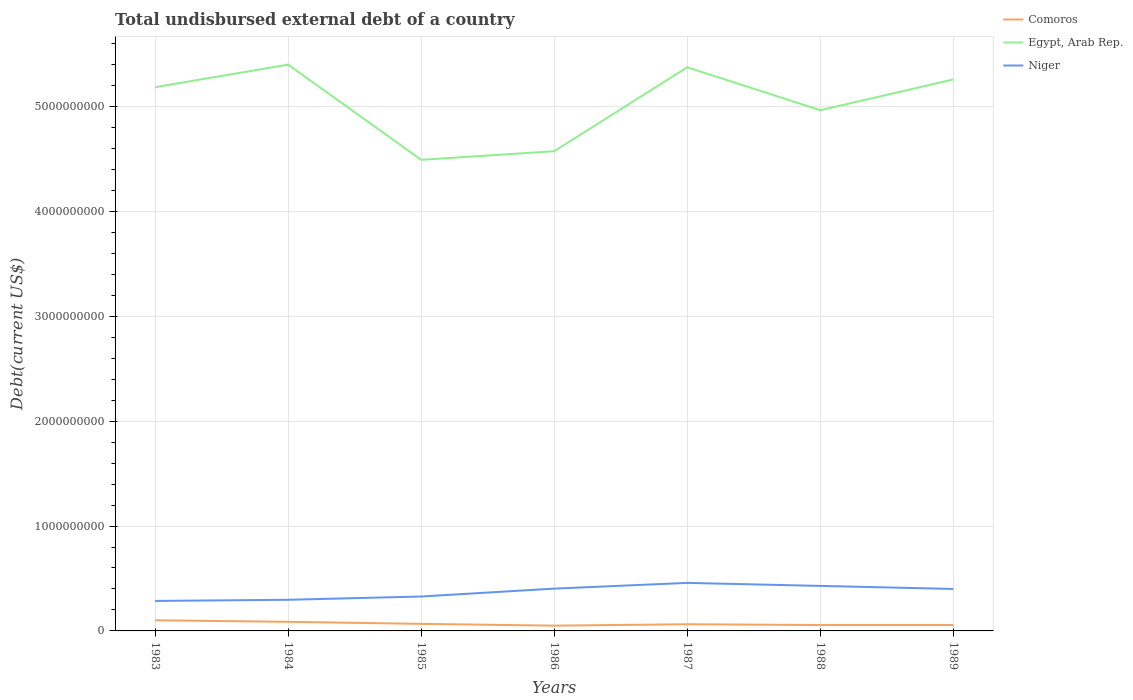Does the line corresponding to Comoros intersect with the line corresponding to Niger?
Keep it short and to the point. No. Is the number of lines equal to the number of legend labels?
Offer a very short reply. Yes. Across all years, what is the maximum total undisbursed external debt in Niger?
Provide a short and direct response. 2.86e+08. What is the total total undisbursed external debt in Egypt, Arab Rep. in the graph?
Your answer should be very brief. -8.00e+08. What is the difference between the highest and the second highest total undisbursed external debt in Egypt, Arab Rep.?
Your answer should be compact. 9.08e+08. What is the difference between the highest and the lowest total undisbursed external debt in Niger?
Your response must be concise. 4. Is the total undisbursed external debt in Niger strictly greater than the total undisbursed external debt in Egypt, Arab Rep. over the years?
Ensure brevity in your answer.  Yes. How many lines are there?
Your response must be concise. 3. How many years are there in the graph?
Provide a succinct answer. 7. What is the difference between two consecutive major ticks on the Y-axis?
Keep it short and to the point. 1.00e+09. Does the graph contain any zero values?
Provide a short and direct response. No. Does the graph contain grids?
Your answer should be compact. Yes. Where does the legend appear in the graph?
Offer a very short reply. Top right. How are the legend labels stacked?
Keep it short and to the point. Vertical. What is the title of the graph?
Your answer should be very brief. Total undisbursed external debt of a country. Does "Fiji" appear as one of the legend labels in the graph?
Keep it short and to the point. No. What is the label or title of the X-axis?
Provide a short and direct response. Years. What is the label or title of the Y-axis?
Offer a very short reply. Debt(current US$). What is the Debt(current US$) of Comoros in 1983?
Ensure brevity in your answer.  1.01e+08. What is the Debt(current US$) in Egypt, Arab Rep. in 1983?
Offer a very short reply. 5.18e+09. What is the Debt(current US$) in Niger in 1983?
Give a very brief answer. 2.86e+08. What is the Debt(current US$) in Comoros in 1984?
Your response must be concise. 8.66e+07. What is the Debt(current US$) of Egypt, Arab Rep. in 1984?
Give a very brief answer. 5.40e+09. What is the Debt(current US$) of Niger in 1984?
Make the answer very short. 2.97e+08. What is the Debt(current US$) in Comoros in 1985?
Offer a very short reply. 6.73e+07. What is the Debt(current US$) in Egypt, Arab Rep. in 1985?
Offer a terse response. 4.49e+09. What is the Debt(current US$) of Niger in 1985?
Your answer should be compact. 3.28e+08. What is the Debt(current US$) in Comoros in 1986?
Ensure brevity in your answer.  5.02e+07. What is the Debt(current US$) of Egypt, Arab Rep. in 1986?
Ensure brevity in your answer.  4.57e+09. What is the Debt(current US$) in Niger in 1986?
Provide a short and direct response. 4.03e+08. What is the Debt(current US$) of Comoros in 1987?
Keep it short and to the point. 6.37e+07. What is the Debt(current US$) of Egypt, Arab Rep. in 1987?
Your answer should be very brief. 5.37e+09. What is the Debt(current US$) in Niger in 1987?
Your answer should be very brief. 4.58e+08. What is the Debt(current US$) in Comoros in 1988?
Ensure brevity in your answer.  5.61e+07. What is the Debt(current US$) in Egypt, Arab Rep. in 1988?
Give a very brief answer. 4.96e+09. What is the Debt(current US$) in Niger in 1988?
Your answer should be compact. 4.29e+08. What is the Debt(current US$) of Comoros in 1989?
Your response must be concise. 5.61e+07. What is the Debt(current US$) in Egypt, Arab Rep. in 1989?
Ensure brevity in your answer.  5.26e+09. What is the Debt(current US$) in Niger in 1989?
Give a very brief answer. 4.00e+08. Across all years, what is the maximum Debt(current US$) of Comoros?
Your answer should be compact. 1.01e+08. Across all years, what is the maximum Debt(current US$) of Egypt, Arab Rep.?
Your answer should be compact. 5.40e+09. Across all years, what is the maximum Debt(current US$) of Niger?
Your answer should be very brief. 4.58e+08. Across all years, what is the minimum Debt(current US$) in Comoros?
Keep it short and to the point. 5.02e+07. Across all years, what is the minimum Debt(current US$) in Egypt, Arab Rep.?
Your answer should be compact. 4.49e+09. Across all years, what is the minimum Debt(current US$) in Niger?
Provide a short and direct response. 2.86e+08. What is the total Debt(current US$) of Comoros in the graph?
Make the answer very short. 4.82e+08. What is the total Debt(current US$) in Egypt, Arab Rep. in the graph?
Offer a terse response. 3.52e+1. What is the total Debt(current US$) in Niger in the graph?
Provide a succinct answer. 2.60e+09. What is the difference between the Debt(current US$) in Comoros in 1983 and that in 1984?
Give a very brief answer. 1.48e+07. What is the difference between the Debt(current US$) in Egypt, Arab Rep. in 1983 and that in 1984?
Your answer should be compact. -2.15e+08. What is the difference between the Debt(current US$) of Niger in 1983 and that in 1984?
Your response must be concise. -1.10e+07. What is the difference between the Debt(current US$) in Comoros in 1983 and that in 1985?
Make the answer very short. 3.41e+07. What is the difference between the Debt(current US$) of Egypt, Arab Rep. in 1983 and that in 1985?
Ensure brevity in your answer.  6.93e+08. What is the difference between the Debt(current US$) in Niger in 1983 and that in 1985?
Offer a very short reply. -4.22e+07. What is the difference between the Debt(current US$) of Comoros in 1983 and that in 1986?
Your answer should be compact. 5.13e+07. What is the difference between the Debt(current US$) in Egypt, Arab Rep. in 1983 and that in 1986?
Provide a short and direct response. 6.11e+08. What is the difference between the Debt(current US$) in Niger in 1983 and that in 1986?
Your response must be concise. -1.17e+08. What is the difference between the Debt(current US$) of Comoros in 1983 and that in 1987?
Make the answer very short. 3.77e+07. What is the difference between the Debt(current US$) in Egypt, Arab Rep. in 1983 and that in 1987?
Provide a short and direct response. -1.90e+08. What is the difference between the Debt(current US$) in Niger in 1983 and that in 1987?
Ensure brevity in your answer.  -1.72e+08. What is the difference between the Debt(current US$) of Comoros in 1983 and that in 1988?
Your answer should be very brief. 4.54e+07. What is the difference between the Debt(current US$) of Egypt, Arab Rep. in 1983 and that in 1988?
Your response must be concise. 2.20e+08. What is the difference between the Debt(current US$) of Niger in 1983 and that in 1988?
Make the answer very short. -1.43e+08. What is the difference between the Debt(current US$) of Comoros in 1983 and that in 1989?
Your response must be concise. 4.53e+07. What is the difference between the Debt(current US$) in Egypt, Arab Rep. in 1983 and that in 1989?
Keep it short and to the point. -7.38e+07. What is the difference between the Debt(current US$) in Niger in 1983 and that in 1989?
Give a very brief answer. -1.14e+08. What is the difference between the Debt(current US$) in Comoros in 1984 and that in 1985?
Your answer should be very brief. 1.93e+07. What is the difference between the Debt(current US$) in Egypt, Arab Rep. in 1984 and that in 1985?
Make the answer very short. 9.08e+08. What is the difference between the Debt(current US$) of Niger in 1984 and that in 1985?
Your answer should be compact. -3.13e+07. What is the difference between the Debt(current US$) of Comoros in 1984 and that in 1986?
Your answer should be very brief. 3.65e+07. What is the difference between the Debt(current US$) in Egypt, Arab Rep. in 1984 and that in 1986?
Give a very brief answer. 8.26e+08. What is the difference between the Debt(current US$) in Niger in 1984 and that in 1986?
Offer a very short reply. -1.07e+08. What is the difference between the Debt(current US$) in Comoros in 1984 and that in 1987?
Your answer should be compact. 2.29e+07. What is the difference between the Debt(current US$) of Egypt, Arab Rep. in 1984 and that in 1987?
Your response must be concise. 2.53e+07. What is the difference between the Debt(current US$) in Niger in 1984 and that in 1987?
Make the answer very short. -1.61e+08. What is the difference between the Debt(current US$) of Comoros in 1984 and that in 1988?
Your answer should be very brief. 3.05e+07. What is the difference between the Debt(current US$) of Egypt, Arab Rep. in 1984 and that in 1988?
Offer a terse response. 4.35e+08. What is the difference between the Debt(current US$) in Niger in 1984 and that in 1988?
Offer a terse response. -1.32e+08. What is the difference between the Debt(current US$) of Comoros in 1984 and that in 1989?
Your answer should be very brief. 3.05e+07. What is the difference between the Debt(current US$) in Egypt, Arab Rep. in 1984 and that in 1989?
Ensure brevity in your answer.  1.41e+08. What is the difference between the Debt(current US$) of Niger in 1984 and that in 1989?
Provide a succinct answer. -1.03e+08. What is the difference between the Debt(current US$) in Comoros in 1985 and that in 1986?
Your response must be concise. 1.72e+07. What is the difference between the Debt(current US$) in Egypt, Arab Rep. in 1985 and that in 1986?
Offer a terse response. -8.19e+07. What is the difference between the Debt(current US$) in Niger in 1985 and that in 1986?
Offer a terse response. -7.53e+07. What is the difference between the Debt(current US$) of Comoros in 1985 and that in 1987?
Offer a very short reply. 3.61e+06. What is the difference between the Debt(current US$) in Egypt, Arab Rep. in 1985 and that in 1987?
Provide a succinct answer. -8.82e+08. What is the difference between the Debt(current US$) in Niger in 1985 and that in 1987?
Offer a very short reply. -1.30e+08. What is the difference between the Debt(current US$) of Comoros in 1985 and that in 1988?
Offer a very short reply. 1.12e+07. What is the difference between the Debt(current US$) of Egypt, Arab Rep. in 1985 and that in 1988?
Your response must be concise. -4.73e+08. What is the difference between the Debt(current US$) of Niger in 1985 and that in 1988?
Your answer should be very brief. -1.01e+08. What is the difference between the Debt(current US$) in Comoros in 1985 and that in 1989?
Your answer should be very brief. 1.12e+07. What is the difference between the Debt(current US$) of Egypt, Arab Rep. in 1985 and that in 1989?
Keep it short and to the point. -7.66e+08. What is the difference between the Debt(current US$) in Niger in 1985 and that in 1989?
Ensure brevity in your answer.  -7.20e+07. What is the difference between the Debt(current US$) in Comoros in 1986 and that in 1987?
Your response must be concise. -1.36e+07. What is the difference between the Debt(current US$) of Egypt, Arab Rep. in 1986 and that in 1987?
Ensure brevity in your answer.  -8.00e+08. What is the difference between the Debt(current US$) of Niger in 1986 and that in 1987?
Keep it short and to the point. -5.46e+07. What is the difference between the Debt(current US$) of Comoros in 1986 and that in 1988?
Provide a succinct answer. -5.94e+06. What is the difference between the Debt(current US$) in Egypt, Arab Rep. in 1986 and that in 1988?
Give a very brief answer. -3.91e+08. What is the difference between the Debt(current US$) of Niger in 1986 and that in 1988?
Provide a succinct answer. -2.58e+07. What is the difference between the Debt(current US$) of Comoros in 1986 and that in 1989?
Ensure brevity in your answer.  -5.96e+06. What is the difference between the Debt(current US$) in Egypt, Arab Rep. in 1986 and that in 1989?
Give a very brief answer. -6.84e+08. What is the difference between the Debt(current US$) of Niger in 1986 and that in 1989?
Your response must be concise. 3.22e+06. What is the difference between the Debt(current US$) in Comoros in 1987 and that in 1988?
Your answer should be very brief. 7.61e+06. What is the difference between the Debt(current US$) of Egypt, Arab Rep. in 1987 and that in 1988?
Your answer should be very brief. 4.09e+08. What is the difference between the Debt(current US$) of Niger in 1987 and that in 1988?
Offer a terse response. 2.88e+07. What is the difference between the Debt(current US$) in Comoros in 1987 and that in 1989?
Provide a succinct answer. 7.58e+06. What is the difference between the Debt(current US$) of Egypt, Arab Rep. in 1987 and that in 1989?
Give a very brief answer. 1.16e+08. What is the difference between the Debt(current US$) of Niger in 1987 and that in 1989?
Offer a very short reply. 5.78e+07. What is the difference between the Debt(current US$) in Comoros in 1988 and that in 1989?
Your answer should be very brief. -2.90e+04. What is the difference between the Debt(current US$) of Egypt, Arab Rep. in 1988 and that in 1989?
Keep it short and to the point. -2.94e+08. What is the difference between the Debt(current US$) in Niger in 1988 and that in 1989?
Your answer should be compact. 2.90e+07. What is the difference between the Debt(current US$) in Comoros in 1983 and the Debt(current US$) in Egypt, Arab Rep. in 1984?
Provide a short and direct response. -5.30e+09. What is the difference between the Debt(current US$) of Comoros in 1983 and the Debt(current US$) of Niger in 1984?
Ensure brevity in your answer.  -1.95e+08. What is the difference between the Debt(current US$) of Egypt, Arab Rep. in 1983 and the Debt(current US$) of Niger in 1984?
Provide a short and direct response. 4.89e+09. What is the difference between the Debt(current US$) of Comoros in 1983 and the Debt(current US$) of Egypt, Arab Rep. in 1985?
Offer a very short reply. -4.39e+09. What is the difference between the Debt(current US$) in Comoros in 1983 and the Debt(current US$) in Niger in 1985?
Provide a succinct answer. -2.27e+08. What is the difference between the Debt(current US$) of Egypt, Arab Rep. in 1983 and the Debt(current US$) of Niger in 1985?
Your answer should be very brief. 4.86e+09. What is the difference between the Debt(current US$) in Comoros in 1983 and the Debt(current US$) in Egypt, Arab Rep. in 1986?
Provide a short and direct response. -4.47e+09. What is the difference between the Debt(current US$) in Comoros in 1983 and the Debt(current US$) in Niger in 1986?
Your response must be concise. -3.02e+08. What is the difference between the Debt(current US$) in Egypt, Arab Rep. in 1983 and the Debt(current US$) in Niger in 1986?
Ensure brevity in your answer.  4.78e+09. What is the difference between the Debt(current US$) of Comoros in 1983 and the Debt(current US$) of Egypt, Arab Rep. in 1987?
Give a very brief answer. -5.27e+09. What is the difference between the Debt(current US$) in Comoros in 1983 and the Debt(current US$) in Niger in 1987?
Keep it short and to the point. -3.56e+08. What is the difference between the Debt(current US$) of Egypt, Arab Rep. in 1983 and the Debt(current US$) of Niger in 1987?
Ensure brevity in your answer.  4.73e+09. What is the difference between the Debt(current US$) in Comoros in 1983 and the Debt(current US$) in Egypt, Arab Rep. in 1988?
Provide a short and direct response. -4.86e+09. What is the difference between the Debt(current US$) of Comoros in 1983 and the Debt(current US$) of Niger in 1988?
Your response must be concise. -3.28e+08. What is the difference between the Debt(current US$) in Egypt, Arab Rep. in 1983 and the Debt(current US$) in Niger in 1988?
Offer a terse response. 4.76e+09. What is the difference between the Debt(current US$) in Comoros in 1983 and the Debt(current US$) in Egypt, Arab Rep. in 1989?
Your answer should be very brief. -5.16e+09. What is the difference between the Debt(current US$) in Comoros in 1983 and the Debt(current US$) in Niger in 1989?
Give a very brief answer. -2.99e+08. What is the difference between the Debt(current US$) in Egypt, Arab Rep. in 1983 and the Debt(current US$) in Niger in 1989?
Make the answer very short. 4.78e+09. What is the difference between the Debt(current US$) in Comoros in 1984 and the Debt(current US$) in Egypt, Arab Rep. in 1985?
Offer a terse response. -4.41e+09. What is the difference between the Debt(current US$) of Comoros in 1984 and the Debt(current US$) of Niger in 1985?
Your answer should be very brief. -2.42e+08. What is the difference between the Debt(current US$) of Egypt, Arab Rep. in 1984 and the Debt(current US$) of Niger in 1985?
Make the answer very short. 5.07e+09. What is the difference between the Debt(current US$) of Comoros in 1984 and the Debt(current US$) of Egypt, Arab Rep. in 1986?
Offer a terse response. -4.49e+09. What is the difference between the Debt(current US$) in Comoros in 1984 and the Debt(current US$) in Niger in 1986?
Ensure brevity in your answer.  -3.17e+08. What is the difference between the Debt(current US$) in Egypt, Arab Rep. in 1984 and the Debt(current US$) in Niger in 1986?
Provide a short and direct response. 5.00e+09. What is the difference between the Debt(current US$) in Comoros in 1984 and the Debt(current US$) in Egypt, Arab Rep. in 1987?
Your response must be concise. -5.29e+09. What is the difference between the Debt(current US$) of Comoros in 1984 and the Debt(current US$) of Niger in 1987?
Ensure brevity in your answer.  -3.71e+08. What is the difference between the Debt(current US$) in Egypt, Arab Rep. in 1984 and the Debt(current US$) in Niger in 1987?
Offer a terse response. 4.94e+09. What is the difference between the Debt(current US$) of Comoros in 1984 and the Debt(current US$) of Egypt, Arab Rep. in 1988?
Your answer should be very brief. -4.88e+09. What is the difference between the Debt(current US$) in Comoros in 1984 and the Debt(current US$) in Niger in 1988?
Give a very brief answer. -3.43e+08. What is the difference between the Debt(current US$) in Egypt, Arab Rep. in 1984 and the Debt(current US$) in Niger in 1988?
Provide a succinct answer. 4.97e+09. What is the difference between the Debt(current US$) in Comoros in 1984 and the Debt(current US$) in Egypt, Arab Rep. in 1989?
Offer a very short reply. -5.17e+09. What is the difference between the Debt(current US$) of Comoros in 1984 and the Debt(current US$) of Niger in 1989?
Offer a terse response. -3.14e+08. What is the difference between the Debt(current US$) of Egypt, Arab Rep. in 1984 and the Debt(current US$) of Niger in 1989?
Your response must be concise. 5.00e+09. What is the difference between the Debt(current US$) in Comoros in 1985 and the Debt(current US$) in Egypt, Arab Rep. in 1986?
Your answer should be very brief. -4.51e+09. What is the difference between the Debt(current US$) of Comoros in 1985 and the Debt(current US$) of Niger in 1986?
Your answer should be compact. -3.36e+08. What is the difference between the Debt(current US$) in Egypt, Arab Rep. in 1985 and the Debt(current US$) in Niger in 1986?
Give a very brief answer. 4.09e+09. What is the difference between the Debt(current US$) of Comoros in 1985 and the Debt(current US$) of Egypt, Arab Rep. in 1987?
Provide a succinct answer. -5.31e+09. What is the difference between the Debt(current US$) of Comoros in 1985 and the Debt(current US$) of Niger in 1987?
Your response must be concise. -3.91e+08. What is the difference between the Debt(current US$) of Egypt, Arab Rep. in 1985 and the Debt(current US$) of Niger in 1987?
Your answer should be very brief. 4.03e+09. What is the difference between the Debt(current US$) of Comoros in 1985 and the Debt(current US$) of Egypt, Arab Rep. in 1988?
Make the answer very short. -4.90e+09. What is the difference between the Debt(current US$) of Comoros in 1985 and the Debt(current US$) of Niger in 1988?
Keep it short and to the point. -3.62e+08. What is the difference between the Debt(current US$) in Egypt, Arab Rep. in 1985 and the Debt(current US$) in Niger in 1988?
Provide a short and direct response. 4.06e+09. What is the difference between the Debt(current US$) in Comoros in 1985 and the Debt(current US$) in Egypt, Arab Rep. in 1989?
Your response must be concise. -5.19e+09. What is the difference between the Debt(current US$) of Comoros in 1985 and the Debt(current US$) of Niger in 1989?
Provide a succinct answer. -3.33e+08. What is the difference between the Debt(current US$) in Egypt, Arab Rep. in 1985 and the Debt(current US$) in Niger in 1989?
Your answer should be very brief. 4.09e+09. What is the difference between the Debt(current US$) in Comoros in 1986 and the Debt(current US$) in Egypt, Arab Rep. in 1987?
Your answer should be very brief. -5.32e+09. What is the difference between the Debt(current US$) of Comoros in 1986 and the Debt(current US$) of Niger in 1987?
Give a very brief answer. -4.08e+08. What is the difference between the Debt(current US$) of Egypt, Arab Rep. in 1986 and the Debt(current US$) of Niger in 1987?
Provide a short and direct response. 4.12e+09. What is the difference between the Debt(current US$) of Comoros in 1986 and the Debt(current US$) of Egypt, Arab Rep. in 1988?
Provide a short and direct response. -4.91e+09. What is the difference between the Debt(current US$) of Comoros in 1986 and the Debt(current US$) of Niger in 1988?
Your response must be concise. -3.79e+08. What is the difference between the Debt(current US$) in Egypt, Arab Rep. in 1986 and the Debt(current US$) in Niger in 1988?
Ensure brevity in your answer.  4.14e+09. What is the difference between the Debt(current US$) of Comoros in 1986 and the Debt(current US$) of Egypt, Arab Rep. in 1989?
Offer a very short reply. -5.21e+09. What is the difference between the Debt(current US$) in Comoros in 1986 and the Debt(current US$) in Niger in 1989?
Your answer should be very brief. -3.50e+08. What is the difference between the Debt(current US$) of Egypt, Arab Rep. in 1986 and the Debt(current US$) of Niger in 1989?
Ensure brevity in your answer.  4.17e+09. What is the difference between the Debt(current US$) in Comoros in 1987 and the Debt(current US$) in Egypt, Arab Rep. in 1988?
Offer a terse response. -4.90e+09. What is the difference between the Debt(current US$) in Comoros in 1987 and the Debt(current US$) in Niger in 1988?
Your answer should be very brief. -3.65e+08. What is the difference between the Debt(current US$) in Egypt, Arab Rep. in 1987 and the Debt(current US$) in Niger in 1988?
Keep it short and to the point. 4.94e+09. What is the difference between the Debt(current US$) of Comoros in 1987 and the Debt(current US$) of Egypt, Arab Rep. in 1989?
Offer a terse response. -5.19e+09. What is the difference between the Debt(current US$) in Comoros in 1987 and the Debt(current US$) in Niger in 1989?
Provide a short and direct response. -3.36e+08. What is the difference between the Debt(current US$) in Egypt, Arab Rep. in 1987 and the Debt(current US$) in Niger in 1989?
Provide a short and direct response. 4.97e+09. What is the difference between the Debt(current US$) of Comoros in 1988 and the Debt(current US$) of Egypt, Arab Rep. in 1989?
Provide a succinct answer. -5.20e+09. What is the difference between the Debt(current US$) of Comoros in 1988 and the Debt(current US$) of Niger in 1989?
Give a very brief answer. -3.44e+08. What is the difference between the Debt(current US$) in Egypt, Arab Rep. in 1988 and the Debt(current US$) in Niger in 1989?
Offer a very short reply. 4.56e+09. What is the average Debt(current US$) of Comoros per year?
Provide a short and direct response. 6.88e+07. What is the average Debt(current US$) in Egypt, Arab Rep. per year?
Your response must be concise. 5.04e+09. What is the average Debt(current US$) of Niger per year?
Make the answer very short. 3.72e+08. In the year 1983, what is the difference between the Debt(current US$) in Comoros and Debt(current US$) in Egypt, Arab Rep.?
Give a very brief answer. -5.08e+09. In the year 1983, what is the difference between the Debt(current US$) in Comoros and Debt(current US$) in Niger?
Keep it short and to the point. -1.84e+08. In the year 1983, what is the difference between the Debt(current US$) of Egypt, Arab Rep. and Debt(current US$) of Niger?
Ensure brevity in your answer.  4.90e+09. In the year 1984, what is the difference between the Debt(current US$) in Comoros and Debt(current US$) in Egypt, Arab Rep.?
Make the answer very short. -5.31e+09. In the year 1984, what is the difference between the Debt(current US$) of Comoros and Debt(current US$) of Niger?
Your answer should be very brief. -2.10e+08. In the year 1984, what is the difference between the Debt(current US$) of Egypt, Arab Rep. and Debt(current US$) of Niger?
Give a very brief answer. 5.10e+09. In the year 1985, what is the difference between the Debt(current US$) in Comoros and Debt(current US$) in Egypt, Arab Rep.?
Keep it short and to the point. -4.42e+09. In the year 1985, what is the difference between the Debt(current US$) in Comoros and Debt(current US$) in Niger?
Offer a terse response. -2.61e+08. In the year 1985, what is the difference between the Debt(current US$) in Egypt, Arab Rep. and Debt(current US$) in Niger?
Provide a short and direct response. 4.16e+09. In the year 1986, what is the difference between the Debt(current US$) of Comoros and Debt(current US$) of Egypt, Arab Rep.?
Make the answer very short. -4.52e+09. In the year 1986, what is the difference between the Debt(current US$) of Comoros and Debt(current US$) of Niger?
Your answer should be compact. -3.53e+08. In the year 1986, what is the difference between the Debt(current US$) of Egypt, Arab Rep. and Debt(current US$) of Niger?
Keep it short and to the point. 4.17e+09. In the year 1987, what is the difference between the Debt(current US$) of Comoros and Debt(current US$) of Egypt, Arab Rep.?
Your answer should be very brief. -5.31e+09. In the year 1987, what is the difference between the Debt(current US$) in Comoros and Debt(current US$) in Niger?
Ensure brevity in your answer.  -3.94e+08. In the year 1987, what is the difference between the Debt(current US$) of Egypt, Arab Rep. and Debt(current US$) of Niger?
Give a very brief answer. 4.92e+09. In the year 1988, what is the difference between the Debt(current US$) of Comoros and Debt(current US$) of Egypt, Arab Rep.?
Offer a very short reply. -4.91e+09. In the year 1988, what is the difference between the Debt(current US$) of Comoros and Debt(current US$) of Niger?
Your answer should be very brief. -3.73e+08. In the year 1988, what is the difference between the Debt(current US$) of Egypt, Arab Rep. and Debt(current US$) of Niger?
Make the answer very short. 4.54e+09. In the year 1989, what is the difference between the Debt(current US$) in Comoros and Debt(current US$) in Egypt, Arab Rep.?
Ensure brevity in your answer.  -5.20e+09. In the year 1989, what is the difference between the Debt(current US$) of Comoros and Debt(current US$) of Niger?
Give a very brief answer. -3.44e+08. In the year 1989, what is the difference between the Debt(current US$) in Egypt, Arab Rep. and Debt(current US$) in Niger?
Offer a very short reply. 4.86e+09. What is the ratio of the Debt(current US$) of Comoros in 1983 to that in 1984?
Offer a very short reply. 1.17. What is the ratio of the Debt(current US$) in Egypt, Arab Rep. in 1983 to that in 1984?
Your response must be concise. 0.96. What is the ratio of the Debt(current US$) of Niger in 1983 to that in 1984?
Provide a succinct answer. 0.96. What is the ratio of the Debt(current US$) in Comoros in 1983 to that in 1985?
Your answer should be compact. 1.51. What is the ratio of the Debt(current US$) of Egypt, Arab Rep. in 1983 to that in 1985?
Provide a succinct answer. 1.15. What is the ratio of the Debt(current US$) of Niger in 1983 to that in 1985?
Make the answer very short. 0.87. What is the ratio of the Debt(current US$) in Comoros in 1983 to that in 1986?
Your response must be concise. 2.02. What is the ratio of the Debt(current US$) of Egypt, Arab Rep. in 1983 to that in 1986?
Your answer should be compact. 1.13. What is the ratio of the Debt(current US$) in Niger in 1983 to that in 1986?
Offer a terse response. 0.71. What is the ratio of the Debt(current US$) in Comoros in 1983 to that in 1987?
Give a very brief answer. 1.59. What is the ratio of the Debt(current US$) in Egypt, Arab Rep. in 1983 to that in 1987?
Your response must be concise. 0.96. What is the ratio of the Debt(current US$) of Niger in 1983 to that in 1987?
Keep it short and to the point. 0.62. What is the ratio of the Debt(current US$) of Comoros in 1983 to that in 1988?
Offer a terse response. 1.81. What is the ratio of the Debt(current US$) in Egypt, Arab Rep. in 1983 to that in 1988?
Give a very brief answer. 1.04. What is the ratio of the Debt(current US$) of Niger in 1983 to that in 1988?
Provide a succinct answer. 0.67. What is the ratio of the Debt(current US$) of Comoros in 1983 to that in 1989?
Your response must be concise. 1.81. What is the ratio of the Debt(current US$) of Egypt, Arab Rep. in 1983 to that in 1989?
Keep it short and to the point. 0.99. What is the ratio of the Debt(current US$) in Niger in 1983 to that in 1989?
Your answer should be very brief. 0.71. What is the ratio of the Debt(current US$) of Comoros in 1984 to that in 1985?
Keep it short and to the point. 1.29. What is the ratio of the Debt(current US$) in Egypt, Arab Rep. in 1984 to that in 1985?
Your answer should be compact. 1.2. What is the ratio of the Debt(current US$) in Niger in 1984 to that in 1985?
Your response must be concise. 0.9. What is the ratio of the Debt(current US$) of Comoros in 1984 to that in 1986?
Give a very brief answer. 1.73. What is the ratio of the Debt(current US$) in Egypt, Arab Rep. in 1984 to that in 1986?
Ensure brevity in your answer.  1.18. What is the ratio of the Debt(current US$) of Niger in 1984 to that in 1986?
Your answer should be compact. 0.74. What is the ratio of the Debt(current US$) in Comoros in 1984 to that in 1987?
Keep it short and to the point. 1.36. What is the ratio of the Debt(current US$) in Egypt, Arab Rep. in 1984 to that in 1987?
Offer a terse response. 1. What is the ratio of the Debt(current US$) of Niger in 1984 to that in 1987?
Give a very brief answer. 0.65. What is the ratio of the Debt(current US$) of Comoros in 1984 to that in 1988?
Provide a short and direct response. 1.54. What is the ratio of the Debt(current US$) in Egypt, Arab Rep. in 1984 to that in 1988?
Provide a succinct answer. 1.09. What is the ratio of the Debt(current US$) in Niger in 1984 to that in 1988?
Provide a succinct answer. 0.69. What is the ratio of the Debt(current US$) of Comoros in 1984 to that in 1989?
Offer a terse response. 1.54. What is the ratio of the Debt(current US$) in Egypt, Arab Rep. in 1984 to that in 1989?
Offer a terse response. 1.03. What is the ratio of the Debt(current US$) in Niger in 1984 to that in 1989?
Your answer should be compact. 0.74. What is the ratio of the Debt(current US$) in Comoros in 1985 to that in 1986?
Keep it short and to the point. 1.34. What is the ratio of the Debt(current US$) in Egypt, Arab Rep. in 1985 to that in 1986?
Provide a short and direct response. 0.98. What is the ratio of the Debt(current US$) of Niger in 1985 to that in 1986?
Give a very brief answer. 0.81. What is the ratio of the Debt(current US$) in Comoros in 1985 to that in 1987?
Offer a terse response. 1.06. What is the ratio of the Debt(current US$) in Egypt, Arab Rep. in 1985 to that in 1987?
Your response must be concise. 0.84. What is the ratio of the Debt(current US$) in Niger in 1985 to that in 1987?
Give a very brief answer. 0.72. What is the ratio of the Debt(current US$) in Comoros in 1985 to that in 1988?
Keep it short and to the point. 1.2. What is the ratio of the Debt(current US$) of Egypt, Arab Rep. in 1985 to that in 1988?
Offer a terse response. 0.9. What is the ratio of the Debt(current US$) of Niger in 1985 to that in 1988?
Ensure brevity in your answer.  0.76. What is the ratio of the Debt(current US$) in Comoros in 1985 to that in 1989?
Provide a short and direct response. 1.2. What is the ratio of the Debt(current US$) of Egypt, Arab Rep. in 1985 to that in 1989?
Make the answer very short. 0.85. What is the ratio of the Debt(current US$) in Niger in 1985 to that in 1989?
Ensure brevity in your answer.  0.82. What is the ratio of the Debt(current US$) of Comoros in 1986 to that in 1987?
Your response must be concise. 0.79. What is the ratio of the Debt(current US$) in Egypt, Arab Rep. in 1986 to that in 1987?
Your response must be concise. 0.85. What is the ratio of the Debt(current US$) of Niger in 1986 to that in 1987?
Your answer should be very brief. 0.88. What is the ratio of the Debt(current US$) in Comoros in 1986 to that in 1988?
Offer a terse response. 0.89. What is the ratio of the Debt(current US$) of Egypt, Arab Rep. in 1986 to that in 1988?
Your answer should be compact. 0.92. What is the ratio of the Debt(current US$) in Niger in 1986 to that in 1988?
Provide a short and direct response. 0.94. What is the ratio of the Debt(current US$) in Comoros in 1986 to that in 1989?
Your answer should be very brief. 0.89. What is the ratio of the Debt(current US$) of Egypt, Arab Rep. in 1986 to that in 1989?
Provide a succinct answer. 0.87. What is the ratio of the Debt(current US$) of Niger in 1986 to that in 1989?
Provide a succinct answer. 1.01. What is the ratio of the Debt(current US$) of Comoros in 1987 to that in 1988?
Give a very brief answer. 1.14. What is the ratio of the Debt(current US$) of Egypt, Arab Rep. in 1987 to that in 1988?
Offer a terse response. 1.08. What is the ratio of the Debt(current US$) in Niger in 1987 to that in 1988?
Provide a short and direct response. 1.07. What is the ratio of the Debt(current US$) in Comoros in 1987 to that in 1989?
Your answer should be very brief. 1.14. What is the ratio of the Debt(current US$) of Egypt, Arab Rep. in 1987 to that in 1989?
Offer a terse response. 1.02. What is the ratio of the Debt(current US$) of Niger in 1987 to that in 1989?
Ensure brevity in your answer.  1.14. What is the ratio of the Debt(current US$) of Egypt, Arab Rep. in 1988 to that in 1989?
Keep it short and to the point. 0.94. What is the ratio of the Debt(current US$) in Niger in 1988 to that in 1989?
Provide a short and direct response. 1.07. What is the difference between the highest and the second highest Debt(current US$) in Comoros?
Provide a succinct answer. 1.48e+07. What is the difference between the highest and the second highest Debt(current US$) of Egypt, Arab Rep.?
Offer a terse response. 2.53e+07. What is the difference between the highest and the second highest Debt(current US$) of Niger?
Offer a very short reply. 2.88e+07. What is the difference between the highest and the lowest Debt(current US$) in Comoros?
Offer a very short reply. 5.13e+07. What is the difference between the highest and the lowest Debt(current US$) in Egypt, Arab Rep.?
Ensure brevity in your answer.  9.08e+08. What is the difference between the highest and the lowest Debt(current US$) in Niger?
Keep it short and to the point. 1.72e+08. 